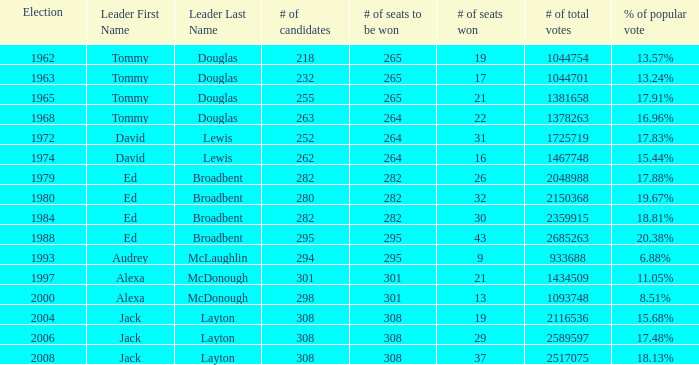Name the number of seats to be won being % of popular vote at 6.88% 295.0. 